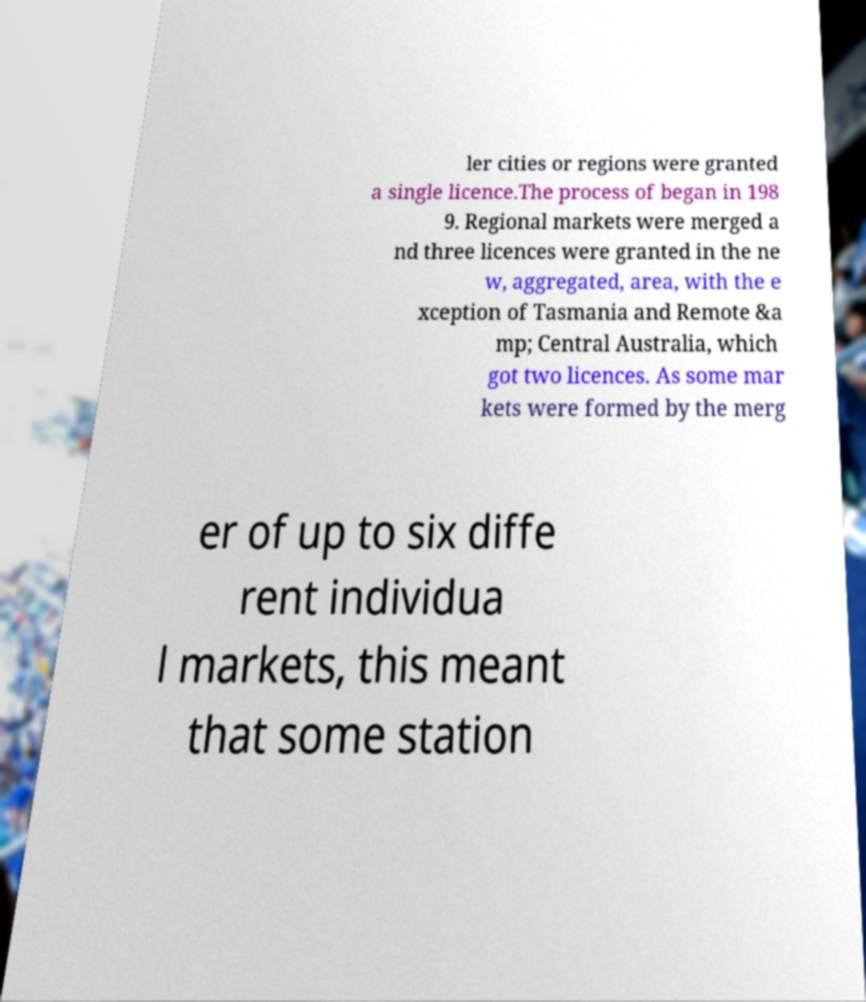Can you accurately transcribe the text from the provided image for me? ler cities or regions were granted a single licence.The process of began in 198 9. Regional markets were merged a nd three licences were granted in the ne w, aggregated, area, with the e xception of Tasmania and Remote &a mp; Central Australia, which got two licences. As some mar kets were formed by the merg er of up to six diffe rent individua l markets, this meant that some station 